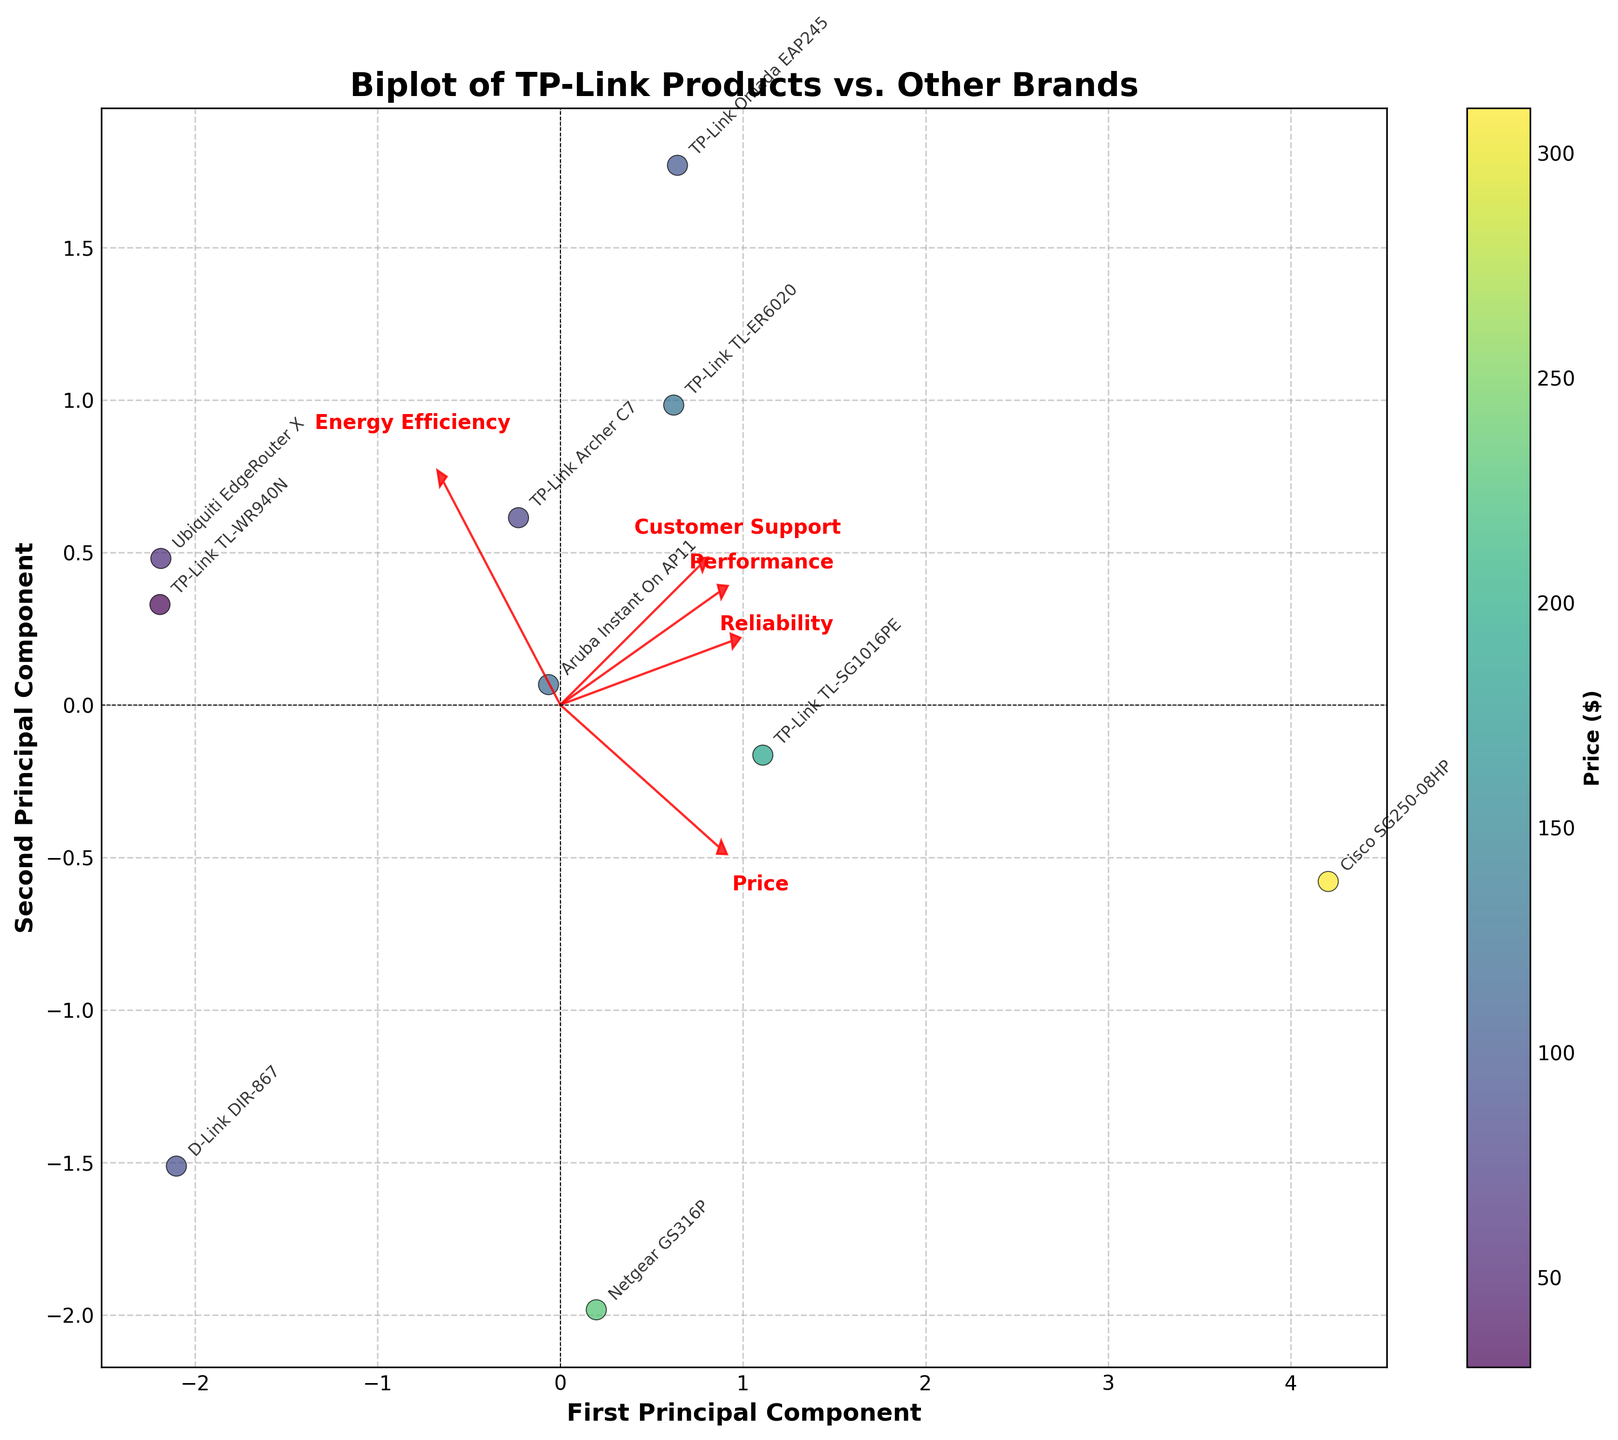Which product is annotated near the highest right point in the biplot? Look for the product name annotation nearest the point furthest to the right of the plot.
Answer: Cisco SG250-08HP What is the main observation about TP-Link's price in comparison to other brands? Check the color gradient on the scatter points which represents price; darker points indicate a lower price. Notice if the TP-Link products are predominantly in a darker shade compared to others.
Answer: Generally, TP-Link has lower prices Which feature vector appears to be most related to the second principal component? Observe the arrows (feature vectors) on the plot; the one with the longest projection along the vertical axis (second principal component) is most related.
Answer: Customer Support Which product has the lowest price and where is it located on the biplot? Identify the product with the lowest price from the color gradient and locate its position on the plot using its annotation name.
Answer: TP-Link TL-WR940N, near the bottom left Which product provides the highest performance according to the biplot? Locate the product annotation corresponding to the highest performance score by checking the position in the direction of the "Performance" feature vector.
Answer: Cisco SG250-08HP Compare the energy efficiency between TP-Link Omada EAP245 and Ubiquiti EdgeRouter X using the biplot. Which one is better? Identify the locations of TP-Link Omada EAP245 and Ubiquiti EdgeRouter X annotations, and see which point is closer to the "Energy Efficiency" feature vector.
Answer: TP-Link Omada EAP245 How many TP-Link products are shown on the biplot? Count the number of annotated points corresponding to TP-Link products on the plot.
Answer: 5 Which feature appears to least contribute to the first principal component? Look at the arrows on the plot and determine which one has the least extension along the horizontal axis (first principal component).
Answer: Energy Efficiency 